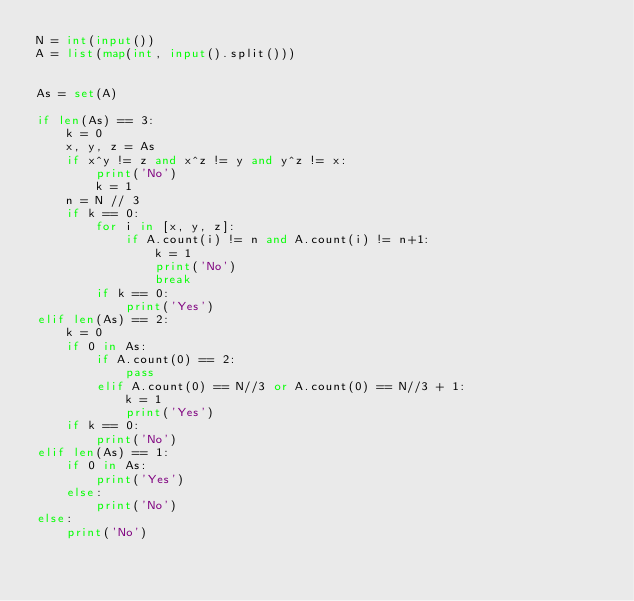<code> <loc_0><loc_0><loc_500><loc_500><_Python_>N = int(input())
A = list(map(int, input().split()))


As = set(A)

if len(As) == 3:
    k = 0
    x, y, z = As
    if x^y != z and x^z != y and y^z != x:
        print('No')
        k = 1
    n = N // 3
    if k == 0:
        for i in [x, y, z]:
            if A.count(i) != n and A.count(i) != n+1:
                k = 1
                print('No')
                break
        if k == 0:
            print('Yes')
elif len(As) == 2:
    k = 0
    if 0 in As:
        if A.count(0) == 2:
            pass
        elif A.count(0) == N//3 or A.count(0) == N//3 + 1:
            k = 1
            print('Yes')
    if k == 0:
        print('No')
elif len(As) == 1:
    if 0 in As:
        print('Yes')
    else:
        print('No')
else:
    print('No')
</code> 